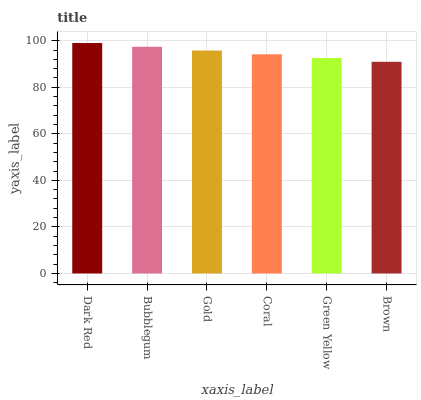Is Brown the minimum?
Answer yes or no. Yes. Is Dark Red the maximum?
Answer yes or no. Yes. Is Bubblegum the minimum?
Answer yes or no. No. Is Bubblegum the maximum?
Answer yes or no. No. Is Dark Red greater than Bubblegum?
Answer yes or no. Yes. Is Bubblegum less than Dark Red?
Answer yes or no. Yes. Is Bubblegum greater than Dark Red?
Answer yes or no. No. Is Dark Red less than Bubblegum?
Answer yes or no. No. Is Gold the high median?
Answer yes or no. Yes. Is Coral the low median?
Answer yes or no. Yes. Is Bubblegum the high median?
Answer yes or no. No. Is Bubblegum the low median?
Answer yes or no. No. 